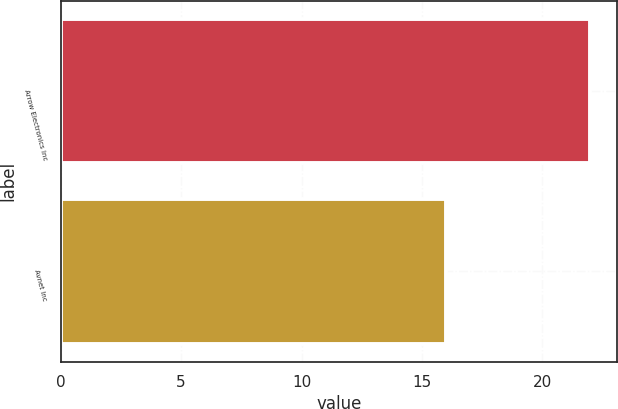Convert chart. <chart><loc_0><loc_0><loc_500><loc_500><bar_chart><fcel>Arrow Electronics Inc<fcel>Avnet Inc<nl><fcel>22<fcel>16<nl></chart> 